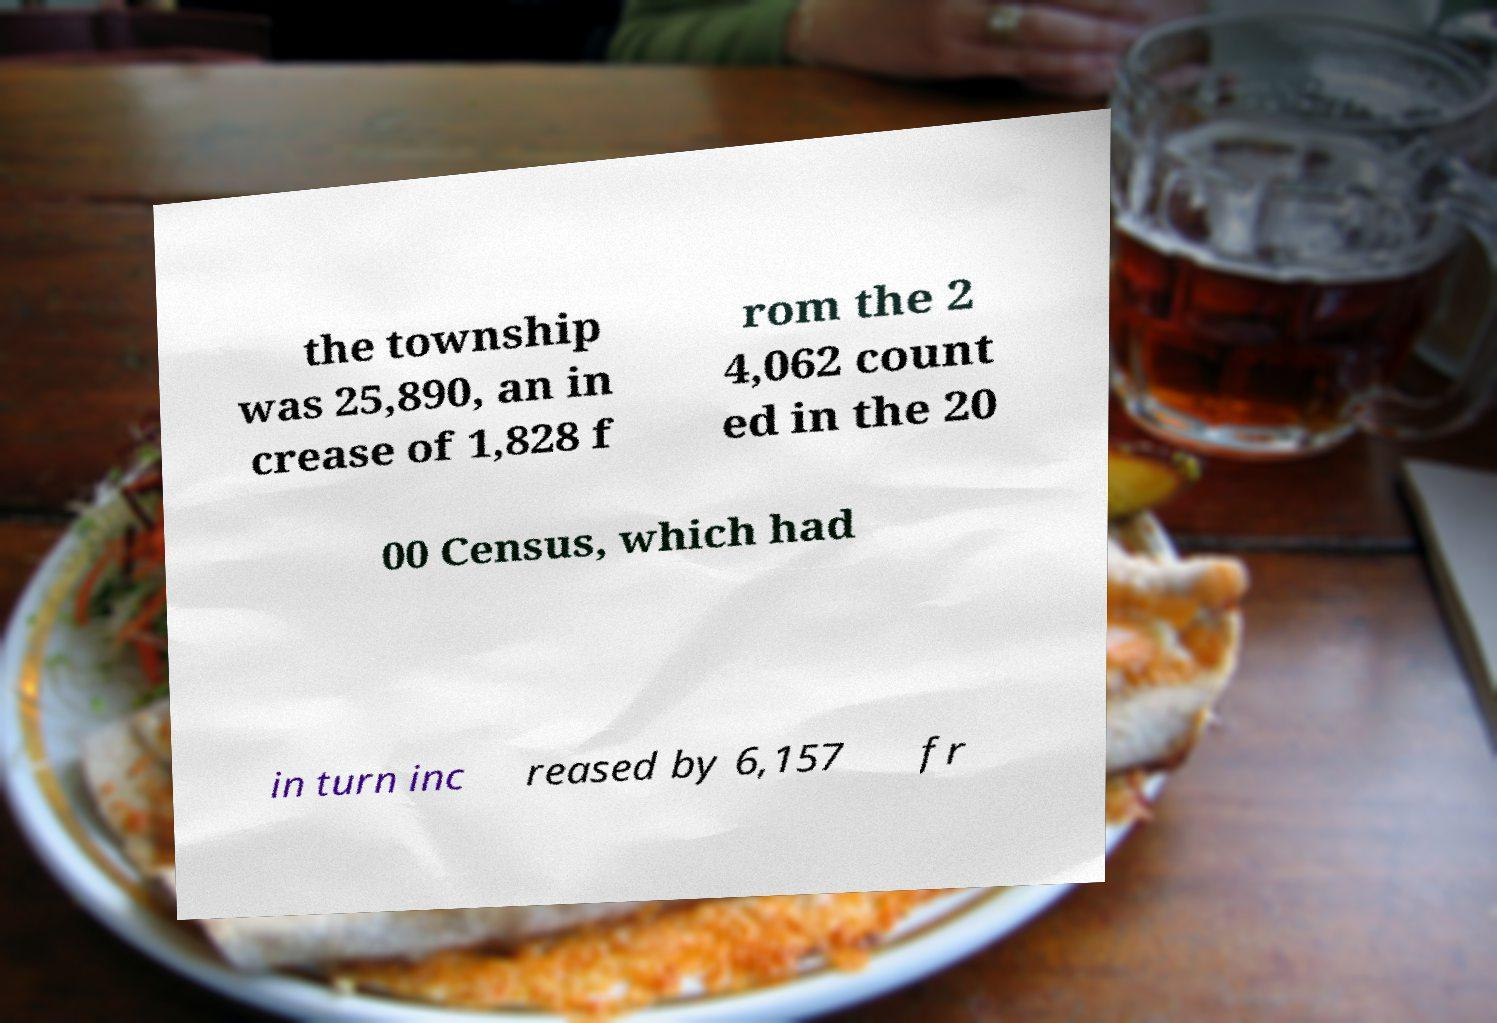Please read and relay the text visible in this image. What does it say? the township was 25,890, an in crease of 1,828 f rom the 2 4,062 count ed in the 20 00 Census, which had in turn inc reased by 6,157 fr 